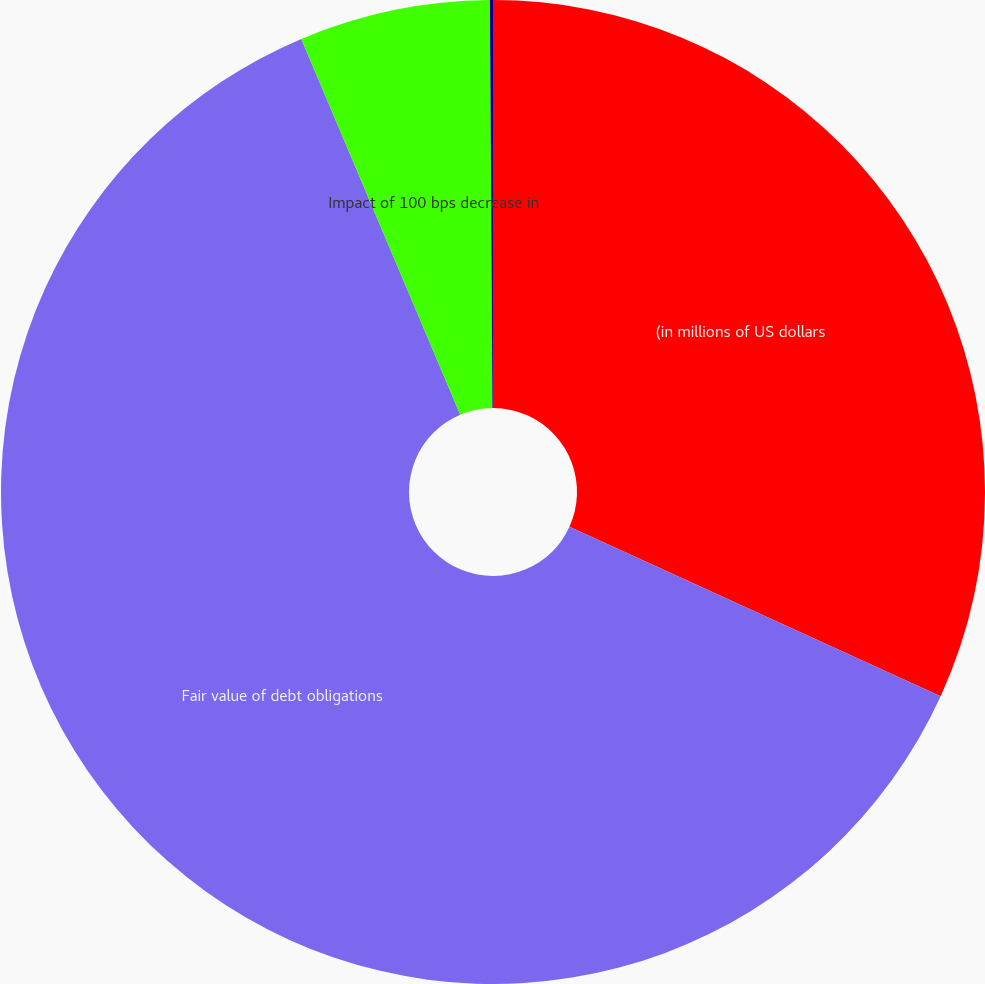<chart> <loc_0><loc_0><loc_500><loc_500><pie_chart><fcel>(in millions of US dollars<fcel>Fair value of debt obligations<fcel>Impact of 100 bps decrease in<fcel>Percentage of total debt<nl><fcel>31.81%<fcel>61.82%<fcel>6.27%<fcel>0.1%<nl></chart> 